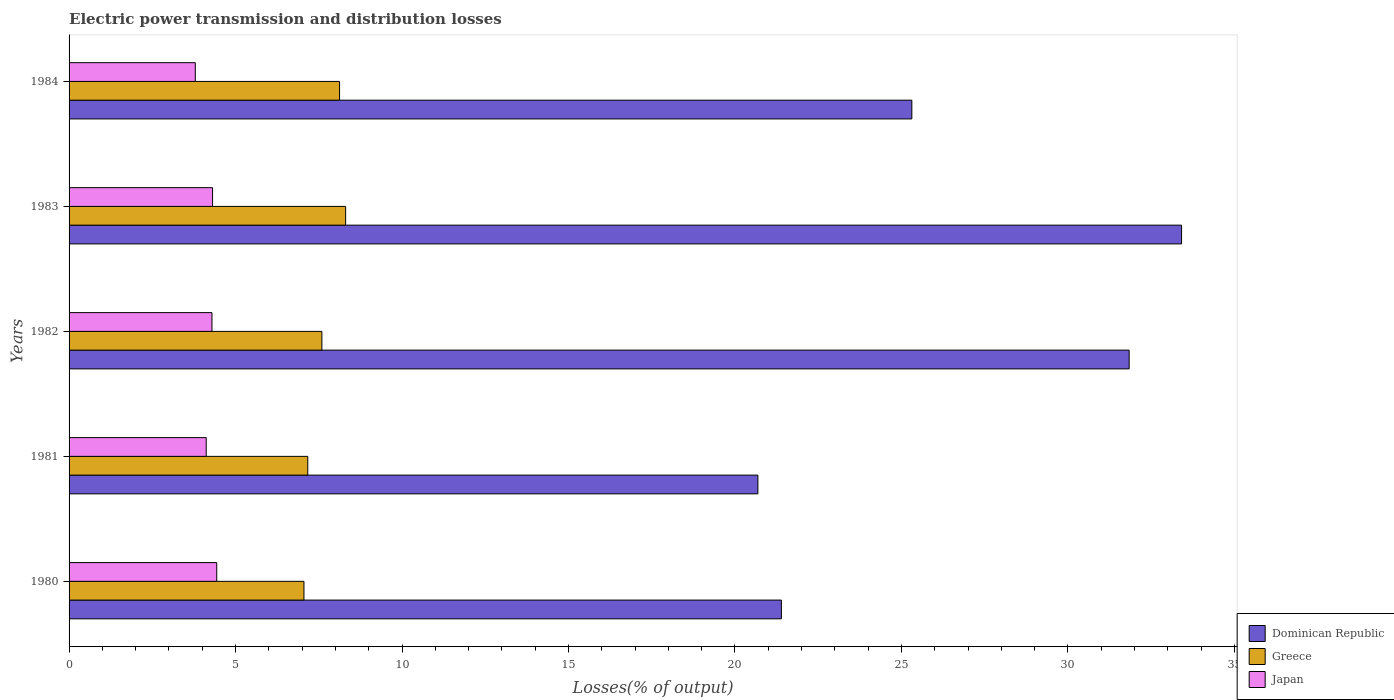How many bars are there on the 1st tick from the bottom?
Give a very brief answer. 3. What is the label of the 2nd group of bars from the top?
Offer a very short reply. 1983. In how many cases, is the number of bars for a given year not equal to the number of legend labels?
Provide a succinct answer. 0. What is the electric power transmission and distribution losses in Dominican Republic in 1982?
Your response must be concise. 31.84. Across all years, what is the maximum electric power transmission and distribution losses in Japan?
Give a very brief answer. 4.43. Across all years, what is the minimum electric power transmission and distribution losses in Dominican Republic?
Offer a very short reply. 20.69. In which year was the electric power transmission and distribution losses in Dominican Republic minimum?
Make the answer very short. 1981. What is the total electric power transmission and distribution losses in Dominican Republic in the graph?
Offer a terse response. 132.64. What is the difference between the electric power transmission and distribution losses in Japan in 1980 and that in 1984?
Your response must be concise. 0.64. What is the difference between the electric power transmission and distribution losses in Dominican Republic in 1980 and the electric power transmission and distribution losses in Japan in 1983?
Keep it short and to the point. 17.08. What is the average electric power transmission and distribution losses in Dominican Republic per year?
Ensure brevity in your answer.  26.53. In the year 1981, what is the difference between the electric power transmission and distribution losses in Japan and electric power transmission and distribution losses in Greece?
Provide a succinct answer. -3.05. In how many years, is the electric power transmission and distribution losses in Japan greater than 3 %?
Keep it short and to the point. 5. What is the ratio of the electric power transmission and distribution losses in Greece in 1981 to that in 1982?
Provide a short and direct response. 0.94. Is the electric power transmission and distribution losses in Dominican Republic in 1980 less than that in 1981?
Ensure brevity in your answer.  No. Is the difference between the electric power transmission and distribution losses in Japan in 1980 and 1982 greater than the difference between the electric power transmission and distribution losses in Greece in 1980 and 1982?
Provide a succinct answer. Yes. What is the difference between the highest and the second highest electric power transmission and distribution losses in Japan?
Keep it short and to the point. 0.13. What is the difference between the highest and the lowest electric power transmission and distribution losses in Japan?
Make the answer very short. 0.64. In how many years, is the electric power transmission and distribution losses in Japan greater than the average electric power transmission and distribution losses in Japan taken over all years?
Ensure brevity in your answer.  3. What does the 3rd bar from the top in 1981 represents?
Provide a short and direct response. Dominican Republic. What does the 3rd bar from the bottom in 1984 represents?
Your answer should be compact. Japan. How many bars are there?
Give a very brief answer. 15. Are all the bars in the graph horizontal?
Your response must be concise. Yes. Does the graph contain any zero values?
Offer a terse response. No. What is the title of the graph?
Provide a short and direct response. Electric power transmission and distribution losses. Does "Middle East & North Africa (all income levels)" appear as one of the legend labels in the graph?
Your answer should be very brief. No. What is the label or title of the X-axis?
Your response must be concise. Losses(% of output). What is the Losses(% of output) of Dominican Republic in 1980?
Keep it short and to the point. 21.39. What is the Losses(% of output) in Greece in 1980?
Make the answer very short. 7.05. What is the Losses(% of output) in Japan in 1980?
Offer a terse response. 4.43. What is the Losses(% of output) of Dominican Republic in 1981?
Provide a succinct answer. 20.69. What is the Losses(% of output) in Greece in 1981?
Keep it short and to the point. 7.17. What is the Losses(% of output) in Japan in 1981?
Ensure brevity in your answer.  4.12. What is the Losses(% of output) in Dominican Republic in 1982?
Make the answer very short. 31.84. What is the Losses(% of output) in Greece in 1982?
Offer a terse response. 7.59. What is the Losses(% of output) in Japan in 1982?
Provide a succinct answer. 4.29. What is the Losses(% of output) of Dominican Republic in 1983?
Your response must be concise. 33.41. What is the Losses(% of output) of Greece in 1983?
Offer a very short reply. 8.31. What is the Losses(% of output) in Japan in 1983?
Your response must be concise. 4.31. What is the Losses(% of output) of Dominican Republic in 1984?
Your answer should be very brief. 25.31. What is the Losses(% of output) of Greece in 1984?
Ensure brevity in your answer.  8.12. What is the Losses(% of output) of Japan in 1984?
Offer a very short reply. 3.79. Across all years, what is the maximum Losses(% of output) in Dominican Republic?
Give a very brief answer. 33.41. Across all years, what is the maximum Losses(% of output) of Greece?
Provide a short and direct response. 8.31. Across all years, what is the maximum Losses(% of output) in Japan?
Make the answer very short. 4.43. Across all years, what is the minimum Losses(% of output) of Dominican Republic?
Your answer should be very brief. 20.69. Across all years, what is the minimum Losses(% of output) of Greece?
Your answer should be compact. 7.05. Across all years, what is the minimum Losses(% of output) of Japan?
Your answer should be very brief. 3.79. What is the total Losses(% of output) in Dominican Republic in the graph?
Your response must be concise. 132.64. What is the total Losses(% of output) in Greece in the graph?
Ensure brevity in your answer.  38.25. What is the total Losses(% of output) of Japan in the graph?
Offer a terse response. 20.95. What is the difference between the Losses(% of output) of Dominican Republic in 1980 and that in 1981?
Keep it short and to the point. 0.71. What is the difference between the Losses(% of output) of Greece in 1980 and that in 1981?
Your answer should be very brief. -0.11. What is the difference between the Losses(% of output) of Japan in 1980 and that in 1981?
Offer a very short reply. 0.32. What is the difference between the Losses(% of output) of Dominican Republic in 1980 and that in 1982?
Offer a very short reply. -10.44. What is the difference between the Losses(% of output) in Greece in 1980 and that in 1982?
Ensure brevity in your answer.  -0.54. What is the difference between the Losses(% of output) of Japan in 1980 and that in 1982?
Your answer should be very brief. 0.14. What is the difference between the Losses(% of output) of Dominican Republic in 1980 and that in 1983?
Offer a terse response. -12.02. What is the difference between the Losses(% of output) in Greece in 1980 and that in 1983?
Keep it short and to the point. -1.25. What is the difference between the Losses(% of output) in Japan in 1980 and that in 1983?
Offer a terse response. 0.13. What is the difference between the Losses(% of output) in Dominican Republic in 1980 and that in 1984?
Give a very brief answer. -3.92. What is the difference between the Losses(% of output) of Greece in 1980 and that in 1984?
Your answer should be compact. -1.07. What is the difference between the Losses(% of output) in Japan in 1980 and that in 1984?
Your answer should be very brief. 0.64. What is the difference between the Losses(% of output) in Dominican Republic in 1981 and that in 1982?
Offer a terse response. -11.15. What is the difference between the Losses(% of output) in Greece in 1981 and that in 1982?
Give a very brief answer. -0.42. What is the difference between the Losses(% of output) of Japan in 1981 and that in 1982?
Ensure brevity in your answer.  -0.17. What is the difference between the Losses(% of output) of Dominican Republic in 1981 and that in 1983?
Offer a terse response. -12.72. What is the difference between the Losses(% of output) of Greece in 1981 and that in 1983?
Your answer should be very brief. -1.14. What is the difference between the Losses(% of output) of Japan in 1981 and that in 1983?
Your response must be concise. -0.19. What is the difference between the Losses(% of output) of Dominican Republic in 1981 and that in 1984?
Offer a terse response. -4.62. What is the difference between the Losses(% of output) of Greece in 1981 and that in 1984?
Your answer should be compact. -0.95. What is the difference between the Losses(% of output) in Japan in 1981 and that in 1984?
Ensure brevity in your answer.  0.33. What is the difference between the Losses(% of output) in Dominican Republic in 1982 and that in 1983?
Provide a short and direct response. -1.57. What is the difference between the Losses(% of output) of Greece in 1982 and that in 1983?
Your answer should be compact. -0.71. What is the difference between the Losses(% of output) of Japan in 1982 and that in 1983?
Your answer should be compact. -0.02. What is the difference between the Losses(% of output) in Dominican Republic in 1982 and that in 1984?
Offer a terse response. 6.53. What is the difference between the Losses(% of output) of Greece in 1982 and that in 1984?
Offer a very short reply. -0.53. What is the difference between the Losses(% of output) of Japan in 1982 and that in 1984?
Keep it short and to the point. 0.5. What is the difference between the Losses(% of output) of Dominican Republic in 1983 and that in 1984?
Provide a short and direct response. 8.1. What is the difference between the Losses(% of output) in Greece in 1983 and that in 1984?
Offer a terse response. 0.18. What is the difference between the Losses(% of output) of Japan in 1983 and that in 1984?
Offer a terse response. 0.52. What is the difference between the Losses(% of output) in Dominican Republic in 1980 and the Losses(% of output) in Greece in 1981?
Offer a very short reply. 14.22. What is the difference between the Losses(% of output) of Dominican Republic in 1980 and the Losses(% of output) of Japan in 1981?
Give a very brief answer. 17.27. What is the difference between the Losses(% of output) in Greece in 1980 and the Losses(% of output) in Japan in 1981?
Offer a terse response. 2.94. What is the difference between the Losses(% of output) of Dominican Republic in 1980 and the Losses(% of output) of Greece in 1982?
Give a very brief answer. 13.8. What is the difference between the Losses(% of output) in Dominican Republic in 1980 and the Losses(% of output) in Japan in 1982?
Give a very brief answer. 17.1. What is the difference between the Losses(% of output) in Greece in 1980 and the Losses(% of output) in Japan in 1982?
Ensure brevity in your answer.  2.76. What is the difference between the Losses(% of output) in Dominican Republic in 1980 and the Losses(% of output) in Greece in 1983?
Your answer should be compact. 13.09. What is the difference between the Losses(% of output) in Dominican Republic in 1980 and the Losses(% of output) in Japan in 1983?
Offer a terse response. 17.08. What is the difference between the Losses(% of output) in Greece in 1980 and the Losses(% of output) in Japan in 1983?
Offer a very short reply. 2.74. What is the difference between the Losses(% of output) of Dominican Republic in 1980 and the Losses(% of output) of Greece in 1984?
Your answer should be very brief. 13.27. What is the difference between the Losses(% of output) of Dominican Republic in 1980 and the Losses(% of output) of Japan in 1984?
Your response must be concise. 17.6. What is the difference between the Losses(% of output) in Greece in 1980 and the Losses(% of output) in Japan in 1984?
Your answer should be very brief. 3.26. What is the difference between the Losses(% of output) in Dominican Republic in 1981 and the Losses(% of output) in Greece in 1982?
Give a very brief answer. 13.09. What is the difference between the Losses(% of output) of Dominican Republic in 1981 and the Losses(% of output) of Japan in 1982?
Your answer should be very brief. 16.4. What is the difference between the Losses(% of output) in Greece in 1981 and the Losses(% of output) in Japan in 1982?
Give a very brief answer. 2.88. What is the difference between the Losses(% of output) in Dominican Republic in 1981 and the Losses(% of output) in Greece in 1983?
Make the answer very short. 12.38. What is the difference between the Losses(% of output) in Dominican Republic in 1981 and the Losses(% of output) in Japan in 1983?
Your answer should be very brief. 16.38. What is the difference between the Losses(% of output) of Greece in 1981 and the Losses(% of output) of Japan in 1983?
Offer a terse response. 2.86. What is the difference between the Losses(% of output) of Dominican Republic in 1981 and the Losses(% of output) of Greece in 1984?
Keep it short and to the point. 12.56. What is the difference between the Losses(% of output) of Dominican Republic in 1981 and the Losses(% of output) of Japan in 1984?
Your response must be concise. 16.9. What is the difference between the Losses(% of output) in Greece in 1981 and the Losses(% of output) in Japan in 1984?
Offer a very short reply. 3.38. What is the difference between the Losses(% of output) of Dominican Republic in 1982 and the Losses(% of output) of Greece in 1983?
Give a very brief answer. 23.53. What is the difference between the Losses(% of output) in Dominican Republic in 1982 and the Losses(% of output) in Japan in 1983?
Offer a very short reply. 27.53. What is the difference between the Losses(% of output) of Greece in 1982 and the Losses(% of output) of Japan in 1983?
Your response must be concise. 3.28. What is the difference between the Losses(% of output) in Dominican Republic in 1982 and the Losses(% of output) in Greece in 1984?
Give a very brief answer. 23.71. What is the difference between the Losses(% of output) of Dominican Republic in 1982 and the Losses(% of output) of Japan in 1984?
Your answer should be compact. 28.05. What is the difference between the Losses(% of output) in Greece in 1982 and the Losses(% of output) in Japan in 1984?
Ensure brevity in your answer.  3.8. What is the difference between the Losses(% of output) of Dominican Republic in 1983 and the Losses(% of output) of Greece in 1984?
Ensure brevity in your answer.  25.29. What is the difference between the Losses(% of output) of Dominican Republic in 1983 and the Losses(% of output) of Japan in 1984?
Give a very brief answer. 29.62. What is the difference between the Losses(% of output) in Greece in 1983 and the Losses(% of output) in Japan in 1984?
Your response must be concise. 4.51. What is the average Losses(% of output) in Dominican Republic per year?
Make the answer very short. 26.53. What is the average Losses(% of output) in Greece per year?
Your answer should be very brief. 7.65. What is the average Losses(% of output) in Japan per year?
Your answer should be compact. 4.19. In the year 1980, what is the difference between the Losses(% of output) in Dominican Republic and Losses(% of output) in Greece?
Make the answer very short. 14.34. In the year 1980, what is the difference between the Losses(% of output) in Dominican Republic and Losses(% of output) in Japan?
Provide a short and direct response. 16.96. In the year 1980, what is the difference between the Losses(% of output) in Greece and Losses(% of output) in Japan?
Provide a succinct answer. 2.62. In the year 1981, what is the difference between the Losses(% of output) of Dominican Republic and Losses(% of output) of Greece?
Ensure brevity in your answer.  13.52. In the year 1981, what is the difference between the Losses(% of output) in Dominican Republic and Losses(% of output) in Japan?
Your answer should be compact. 16.57. In the year 1981, what is the difference between the Losses(% of output) of Greece and Losses(% of output) of Japan?
Your response must be concise. 3.05. In the year 1982, what is the difference between the Losses(% of output) of Dominican Republic and Losses(% of output) of Greece?
Give a very brief answer. 24.25. In the year 1982, what is the difference between the Losses(% of output) in Dominican Republic and Losses(% of output) in Japan?
Provide a succinct answer. 27.55. In the year 1982, what is the difference between the Losses(% of output) of Greece and Losses(% of output) of Japan?
Keep it short and to the point. 3.3. In the year 1983, what is the difference between the Losses(% of output) of Dominican Republic and Losses(% of output) of Greece?
Offer a very short reply. 25.11. In the year 1983, what is the difference between the Losses(% of output) of Dominican Republic and Losses(% of output) of Japan?
Your answer should be compact. 29.1. In the year 1983, what is the difference between the Losses(% of output) of Greece and Losses(% of output) of Japan?
Give a very brief answer. 4. In the year 1984, what is the difference between the Losses(% of output) of Dominican Republic and Losses(% of output) of Greece?
Ensure brevity in your answer.  17.19. In the year 1984, what is the difference between the Losses(% of output) in Dominican Republic and Losses(% of output) in Japan?
Offer a terse response. 21.52. In the year 1984, what is the difference between the Losses(% of output) in Greece and Losses(% of output) in Japan?
Your response must be concise. 4.33. What is the ratio of the Losses(% of output) in Dominican Republic in 1980 to that in 1981?
Provide a short and direct response. 1.03. What is the ratio of the Losses(% of output) in Greece in 1980 to that in 1981?
Your answer should be very brief. 0.98. What is the ratio of the Losses(% of output) of Japan in 1980 to that in 1981?
Make the answer very short. 1.08. What is the ratio of the Losses(% of output) in Dominican Republic in 1980 to that in 1982?
Provide a short and direct response. 0.67. What is the ratio of the Losses(% of output) in Greece in 1980 to that in 1982?
Ensure brevity in your answer.  0.93. What is the ratio of the Losses(% of output) of Japan in 1980 to that in 1982?
Keep it short and to the point. 1.03. What is the ratio of the Losses(% of output) of Dominican Republic in 1980 to that in 1983?
Your answer should be compact. 0.64. What is the ratio of the Losses(% of output) of Greece in 1980 to that in 1983?
Make the answer very short. 0.85. What is the ratio of the Losses(% of output) in Dominican Republic in 1980 to that in 1984?
Your answer should be very brief. 0.85. What is the ratio of the Losses(% of output) of Greece in 1980 to that in 1984?
Offer a terse response. 0.87. What is the ratio of the Losses(% of output) of Japan in 1980 to that in 1984?
Offer a very short reply. 1.17. What is the ratio of the Losses(% of output) of Dominican Republic in 1981 to that in 1982?
Offer a very short reply. 0.65. What is the ratio of the Losses(% of output) of Greece in 1981 to that in 1982?
Provide a succinct answer. 0.94. What is the ratio of the Losses(% of output) in Japan in 1981 to that in 1982?
Your answer should be very brief. 0.96. What is the ratio of the Losses(% of output) of Dominican Republic in 1981 to that in 1983?
Keep it short and to the point. 0.62. What is the ratio of the Losses(% of output) in Greece in 1981 to that in 1983?
Your answer should be very brief. 0.86. What is the ratio of the Losses(% of output) in Japan in 1981 to that in 1983?
Your answer should be compact. 0.96. What is the ratio of the Losses(% of output) of Dominican Republic in 1981 to that in 1984?
Give a very brief answer. 0.82. What is the ratio of the Losses(% of output) in Greece in 1981 to that in 1984?
Offer a terse response. 0.88. What is the ratio of the Losses(% of output) of Japan in 1981 to that in 1984?
Ensure brevity in your answer.  1.09. What is the ratio of the Losses(% of output) of Dominican Republic in 1982 to that in 1983?
Provide a succinct answer. 0.95. What is the ratio of the Losses(% of output) of Greece in 1982 to that in 1983?
Provide a short and direct response. 0.91. What is the ratio of the Losses(% of output) of Japan in 1982 to that in 1983?
Give a very brief answer. 1. What is the ratio of the Losses(% of output) of Dominican Republic in 1982 to that in 1984?
Your answer should be very brief. 1.26. What is the ratio of the Losses(% of output) of Greece in 1982 to that in 1984?
Your response must be concise. 0.93. What is the ratio of the Losses(% of output) in Japan in 1982 to that in 1984?
Offer a very short reply. 1.13. What is the ratio of the Losses(% of output) of Dominican Republic in 1983 to that in 1984?
Offer a terse response. 1.32. What is the ratio of the Losses(% of output) of Greece in 1983 to that in 1984?
Offer a terse response. 1.02. What is the ratio of the Losses(% of output) in Japan in 1983 to that in 1984?
Your answer should be compact. 1.14. What is the difference between the highest and the second highest Losses(% of output) in Dominican Republic?
Give a very brief answer. 1.57. What is the difference between the highest and the second highest Losses(% of output) in Greece?
Your response must be concise. 0.18. What is the difference between the highest and the second highest Losses(% of output) of Japan?
Provide a succinct answer. 0.13. What is the difference between the highest and the lowest Losses(% of output) of Dominican Republic?
Ensure brevity in your answer.  12.72. What is the difference between the highest and the lowest Losses(% of output) in Greece?
Offer a very short reply. 1.25. What is the difference between the highest and the lowest Losses(% of output) of Japan?
Offer a terse response. 0.64. 